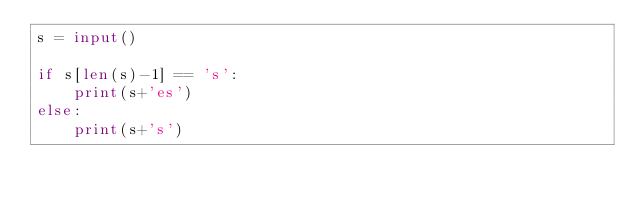<code> <loc_0><loc_0><loc_500><loc_500><_Python_>s = input()

if s[len(s)-1] == 's':
    print(s+'es')
else:
    print(s+'s')  </code> 